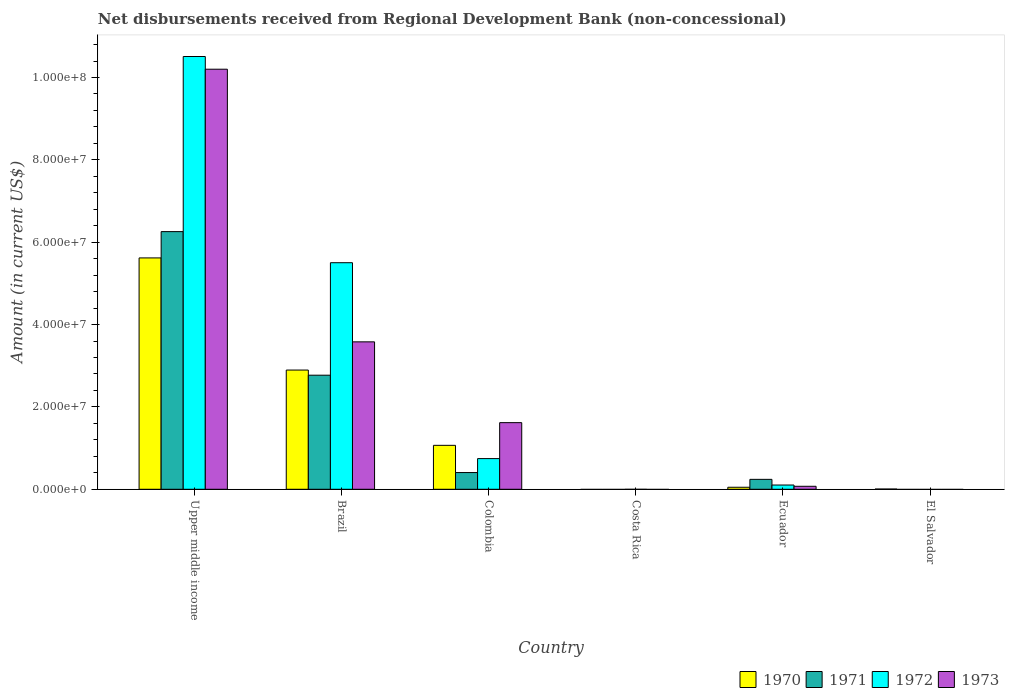How many different coloured bars are there?
Your response must be concise. 4. Are the number of bars per tick equal to the number of legend labels?
Your answer should be very brief. No. Are the number of bars on each tick of the X-axis equal?
Your answer should be very brief. No. How many bars are there on the 5th tick from the left?
Offer a very short reply. 4. How many bars are there on the 5th tick from the right?
Give a very brief answer. 4. What is the label of the 6th group of bars from the left?
Make the answer very short. El Salvador. What is the amount of disbursements received from Regional Development Bank in 1973 in Colombia?
Keep it short and to the point. 1.62e+07. Across all countries, what is the maximum amount of disbursements received from Regional Development Bank in 1973?
Offer a very short reply. 1.02e+08. Across all countries, what is the minimum amount of disbursements received from Regional Development Bank in 1973?
Provide a succinct answer. 0. In which country was the amount of disbursements received from Regional Development Bank in 1973 maximum?
Offer a very short reply. Upper middle income. What is the total amount of disbursements received from Regional Development Bank in 1972 in the graph?
Keep it short and to the point. 1.69e+08. What is the difference between the amount of disbursements received from Regional Development Bank in 1971 in Brazil and that in Ecuador?
Your answer should be compact. 2.53e+07. What is the difference between the amount of disbursements received from Regional Development Bank in 1970 in Upper middle income and the amount of disbursements received from Regional Development Bank in 1971 in Brazil?
Offer a very short reply. 2.85e+07. What is the average amount of disbursements received from Regional Development Bank in 1972 per country?
Ensure brevity in your answer.  2.81e+07. What is the difference between the amount of disbursements received from Regional Development Bank of/in 1973 and amount of disbursements received from Regional Development Bank of/in 1972 in Upper middle income?
Provide a succinct answer. -3.08e+06. What is the ratio of the amount of disbursements received from Regional Development Bank in 1972 in Colombia to that in Upper middle income?
Make the answer very short. 0.07. What is the difference between the highest and the second highest amount of disbursements received from Regional Development Bank in 1973?
Offer a very short reply. 8.58e+07. What is the difference between the highest and the lowest amount of disbursements received from Regional Development Bank in 1971?
Your response must be concise. 6.26e+07. Is the sum of the amount of disbursements received from Regional Development Bank in 1971 in Colombia and Ecuador greater than the maximum amount of disbursements received from Regional Development Bank in 1970 across all countries?
Offer a terse response. No. Is it the case that in every country, the sum of the amount of disbursements received from Regional Development Bank in 1973 and amount of disbursements received from Regional Development Bank in 1971 is greater than the amount of disbursements received from Regional Development Bank in 1970?
Your response must be concise. No. Are all the bars in the graph horizontal?
Provide a short and direct response. No. What is the difference between two consecutive major ticks on the Y-axis?
Your answer should be compact. 2.00e+07. Does the graph contain any zero values?
Provide a succinct answer. Yes. Does the graph contain grids?
Offer a terse response. No. What is the title of the graph?
Offer a terse response. Net disbursements received from Regional Development Bank (non-concessional). What is the Amount (in current US$) of 1970 in Upper middle income?
Give a very brief answer. 5.62e+07. What is the Amount (in current US$) in 1971 in Upper middle income?
Offer a terse response. 6.26e+07. What is the Amount (in current US$) in 1972 in Upper middle income?
Offer a very short reply. 1.05e+08. What is the Amount (in current US$) in 1973 in Upper middle income?
Your answer should be compact. 1.02e+08. What is the Amount (in current US$) in 1970 in Brazil?
Your response must be concise. 2.90e+07. What is the Amount (in current US$) in 1971 in Brazil?
Your answer should be very brief. 2.77e+07. What is the Amount (in current US$) in 1972 in Brazil?
Provide a succinct answer. 5.50e+07. What is the Amount (in current US$) in 1973 in Brazil?
Give a very brief answer. 3.58e+07. What is the Amount (in current US$) of 1970 in Colombia?
Keep it short and to the point. 1.07e+07. What is the Amount (in current US$) of 1971 in Colombia?
Offer a very short reply. 4.06e+06. What is the Amount (in current US$) in 1972 in Colombia?
Keep it short and to the point. 7.45e+06. What is the Amount (in current US$) of 1973 in Colombia?
Ensure brevity in your answer.  1.62e+07. What is the Amount (in current US$) of 1970 in Costa Rica?
Your answer should be compact. 0. What is the Amount (in current US$) of 1971 in Costa Rica?
Your response must be concise. 0. What is the Amount (in current US$) of 1970 in Ecuador?
Give a very brief answer. 4.89e+05. What is the Amount (in current US$) of 1971 in Ecuador?
Keep it short and to the point. 2.41e+06. What is the Amount (in current US$) of 1972 in Ecuador?
Offer a terse response. 1.03e+06. What is the Amount (in current US$) in 1973 in Ecuador?
Your answer should be very brief. 7.26e+05. What is the Amount (in current US$) in 1970 in El Salvador?
Your answer should be compact. 5.70e+04. What is the Amount (in current US$) in 1971 in El Salvador?
Your answer should be compact. 0. Across all countries, what is the maximum Amount (in current US$) in 1970?
Provide a short and direct response. 5.62e+07. Across all countries, what is the maximum Amount (in current US$) of 1971?
Your response must be concise. 6.26e+07. Across all countries, what is the maximum Amount (in current US$) of 1972?
Keep it short and to the point. 1.05e+08. Across all countries, what is the maximum Amount (in current US$) of 1973?
Provide a short and direct response. 1.02e+08. Across all countries, what is the minimum Amount (in current US$) of 1970?
Keep it short and to the point. 0. Across all countries, what is the minimum Amount (in current US$) in 1971?
Provide a succinct answer. 0. Across all countries, what is the minimum Amount (in current US$) of 1972?
Keep it short and to the point. 0. What is the total Amount (in current US$) in 1970 in the graph?
Your response must be concise. 9.64e+07. What is the total Amount (in current US$) in 1971 in the graph?
Make the answer very short. 9.68e+07. What is the total Amount (in current US$) of 1972 in the graph?
Provide a short and direct response. 1.69e+08. What is the total Amount (in current US$) of 1973 in the graph?
Your answer should be very brief. 1.55e+08. What is the difference between the Amount (in current US$) of 1970 in Upper middle income and that in Brazil?
Provide a short and direct response. 2.72e+07. What is the difference between the Amount (in current US$) of 1971 in Upper middle income and that in Brazil?
Your response must be concise. 3.49e+07. What is the difference between the Amount (in current US$) in 1972 in Upper middle income and that in Brazil?
Give a very brief answer. 5.01e+07. What is the difference between the Amount (in current US$) in 1973 in Upper middle income and that in Brazil?
Give a very brief answer. 6.62e+07. What is the difference between the Amount (in current US$) of 1970 in Upper middle income and that in Colombia?
Provide a succinct answer. 4.55e+07. What is the difference between the Amount (in current US$) of 1971 in Upper middle income and that in Colombia?
Provide a succinct answer. 5.85e+07. What is the difference between the Amount (in current US$) of 1972 in Upper middle income and that in Colombia?
Provide a short and direct response. 9.76e+07. What is the difference between the Amount (in current US$) of 1973 in Upper middle income and that in Colombia?
Make the answer very short. 8.58e+07. What is the difference between the Amount (in current US$) in 1970 in Upper middle income and that in Ecuador?
Keep it short and to the point. 5.57e+07. What is the difference between the Amount (in current US$) in 1971 in Upper middle income and that in Ecuador?
Give a very brief answer. 6.02e+07. What is the difference between the Amount (in current US$) of 1972 in Upper middle income and that in Ecuador?
Make the answer very short. 1.04e+08. What is the difference between the Amount (in current US$) in 1973 in Upper middle income and that in Ecuador?
Offer a very short reply. 1.01e+08. What is the difference between the Amount (in current US$) of 1970 in Upper middle income and that in El Salvador?
Keep it short and to the point. 5.61e+07. What is the difference between the Amount (in current US$) in 1970 in Brazil and that in Colombia?
Make the answer very short. 1.83e+07. What is the difference between the Amount (in current US$) of 1971 in Brazil and that in Colombia?
Ensure brevity in your answer.  2.36e+07. What is the difference between the Amount (in current US$) of 1972 in Brazil and that in Colombia?
Give a very brief answer. 4.76e+07. What is the difference between the Amount (in current US$) of 1973 in Brazil and that in Colombia?
Your answer should be compact. 1.96e+07. What is the difference between the Amount (in current US$) in 1970 in Brazil and that in Ecuador?
Offer a terse response. 2.85e+07. What is the difference between the Amount (in current US$) in 1971 in Brazil and that in Ecuador?
Provide a succinct answer. 2.53e+07. What is the difference between the Amount (in current US$) in 1972 in Brazil and that in Ecuador?
Offer a very short reply. 5.40e+07. What is the difference between the Amount (in current US$) of 1973 in Brazil and that in Ecuador?
Provide a short and direct response. 3.51e+07. What is the difference between the Amount (in current US$) of 1970 in Brazil and that in El Salvador?
Provide a succinct answer. 2.89e+07. What is the difference between the Amount (in current US$) of 1970 in Colombia and that in Ecuador?
Your response must be concise. 1.02e+07. What is the difference between the Amount (in current US$) of 1971 in Colombia and that in Ecuador?
Provide a succinct answer. 1.65e+06. What is the difference between the Amount (in current US$) of 1972 in Colombia and that in Ecuador?
Your answer should be very brief. 6.42e+06. What is the difference between the Amount (in current US$) of 1973 in Colombia and that in Ecuador?
Make the answer very short. 1.55e+07. What is the difference between the Amount (in current US$) in 1970 in Colombia and that in El Salvador?
Provide a succinct answer. 1.06e+07. What is the difference between the Amount (in current US$) of 1970 in Ecuador and that in El Salvador?
Your answer should be very brief. 4.32e+05. What is the difference between the Amount (in current US$) of 1970 in Upper middle income and the Amount (in current US$) of 1971 in Brazil?
Give a very brief answer. 2.85e+07. What is the difference between the Amount (in current US$) in 1970 in Upper middle income and the Amount (in current US$) in 1972 in Brazil?
Your answer should be compact. 1.16e+06. What is the difference between the Amount (in current US$) in 1970 in Upper middle income and the Amount (in current US$) in 1973 in Brazil?
Keep it short and to the point. 2.04e+07. What is the difference between the Amount (in current US$) in 1971 in Upper middle income and the Amount (in current US$) in 1972 in Brazil?
Give a very brief answer. 7.55e+06. What is the difference between the Amount (in current US$) of 1971 in Upper middle income and the Amount (in current US$) of 1973 in Brazil?
Give a very brief answer. 2.68e+07. What is the difference between the Amount (in current US$) of 1972 in Upper middle income and the Amount (in current US$) of 1973 in Brazil?
Provide a short and direct response. 6.93e+07. What is the difference between the Amount (in current US$) of 1970 in Upper middle income and the Amount (in current US$) of 1971 in Colombia?
Your answer should be compact. 5.21e+07. What is the difference between the Amount (in current US$) in 1970 in Upper middle income and the Amount (in current US$) in 1972 in Colombia?
Ensure brevity in your answer.  4.87e+07. What is the difference between the Amount (in current US$) in 1970 in Upper middle income and the Amount (in current US$) in 1973 in Colombia?
Your answer should be compact. 4.00e+07. What is the difference between the Amount (in current US$) in 1971 in Upper middle income and the Amount (in current US$) in 1972 in Colombia?
Your answer should be very brief. 5.51e+07. What is the difference between the Amount (in current US$) in 1971 in Upper middle income and the Amount (in current US$) in 1973 in Colombia?
Your answer should be very brief. 4.64e+07. What is the difference between the Amount (in current US$) in 1972 in Upper middle income and the Amount (in current US$) in 1973 in Colombia?
Give a very brief answer. 8.89e+07. What is the difference between the Amount (in current US$) in 1970 in Upper middle income and the Amount (in current US$) in 1971 in Ecuador?
Your answer should be very brief. 5.38e+07. What is the difference between the Amount (in current US$) in 1970 in Upper middle income and the Amount (in current US$) in 1972 in Ecuador?
Your answer should be very brief. 5.52e+07. What is the difference between the Amount (in current US$) in 1970 in Upper middle income and the Amount (in current US$) in 1973 in Ecuador?
Make the answer very short. 5.55e+07. What is the difference between the Amount (in current US$) of 1971 in Upper middle income and the Amount (in current US$) of 1972 in Ecuador?
Your answer should be very brief. 6.15e+07. What is the difference between the Amount (in current US$) of 1971 in Upper middle income and the Amount (in current US$) of 1973 in Ecuador?
Provide a succinct answer. 6.18e+07. What is the difference between the Amount (in current US$) in 1972 in Upper middle income and the Amount (in current US$) in 1973 in Ecuador?
Ensure brevity in your answer.  1.04e+08. What is the difference between the Amount (in current US$) of 1970 in Brazil and the Amount (in current US$) of 1971 in Colombia?
Your response must be concise. 2.49e+07. What is the difference between the Amount (in current US$) of 1970 in Brazil and the Amount (in current US$) of 1972 in Colombia?
Your answer should be compact. 2.15e+07. What is the difference between the Amount (in current US$) of 1970 in Brazil and the Amount (in current US$) of 1973 in Colombia?
Give a very brief answer. 1.28e+07. What is the difference between the Amount (in current US$) of 1971 in Brazil and the Amount (in current US$) of 1972 in Colombia?
Offer a very short reply. 2.03e+07. What is the difference between the Amount (in current US$) in 1971 in Brazil and the Amount (in current US$) in 1973 in Colombia?
Offer a terse response. 1.15e+07. What is the difference between the Amount (in current US$) in 1972 in Brazil and the Amount (in current US$) in 1973 in Colombia?
Make the answer very short. 3.88e+07. What is the difference between the Amount (in current US$) in 1970 in Brazil and the Amount (in current US$) in 1971 in Ecuador?
Your response must be concise. 2.65e+07. What is the difference between the Amount (in current US$) of 1970 in Brazil and the Amount (in current US$) of 1972 in Ecuador?
Ensure brevity in your answer.  2.79e+07. What is the difference between the Amount (in current US$) in 1970 in Brazil and the Amount (in current US$) in 1973 in Ecuador?
Your answer should be very brief. 2.82e+07. What is the difference between the Amount (in current US$) of 1971 in Brazil and the Amount (in current US$) of 1972 in Ecuador?
Offer a very short reply. 2.67e+07. What is the difference between the Amount (in current US$) of 1971 in Brazil and the Amount (in current US$) of 1973 in Ecuador?
Offer a terse response. 2.70e+07. What is the difference between the Amount (in current US$) of 1972 in Brazil and the Amount (in current US$) of 1973 in Ecuador?
Your response must be concise. 5.43e+07. What is the difference between the Amount (in current US$) in 1970 in Colombia and the Amount (in current US$) in 1971 in Ecuador?
Make the answer very short. 8.26e+06. What is the difference between the Amount (in current US$) in 1970 in Colombia and the Amount (in current US$) in 1972 in Ecuador?
Give a very brief answer. 9.64e+06. What is the difference between the Amount (in current US$) in 1970 in Colombia and the Amount (in current US$) in 1973 in Ecuador?
Your answer should be compact. 9.94e+06. What is the difference between the Amount (in current US$) of 1971 in Colombia and the Amount (in current US$) of 1972 in Ecuador?
Make the answer very short. 3.03e+06. What is the difference between the Amount (in current US$) in 1971 in Colombia and the Amount (in current US$) in 1973 in Ecuador?
Ensure brevity in your answer.  3.34e+06. What is the difference between the Amount (in current US$) of 1972 in Colombia and the Amount (in current US$) of 1973 in Ecuador?
Provide a short and direct response. 6.72e+06. What is the average Amount (in current US$) of 1970 per country?
Give a very brief answer. 1.61e+07. What is the average Amount (in current US$) of 1971 per country?
Ensure brevity in your answer.  1.61e+07. What is the average Amount (in current US$) of 1972 per country?
Give a very brief answer. 2.81e+07. What is the average Amount (in current US$) of 1973 per country?
Offer a very short reply. 2.58e+07. What is the difference between the Amount (in current US$) in 1970 and Amount (in current US$) in 1971 in Upper middle income?
Your answer should be compact. -6.39e+06. What is the difference between the Amount (in current US$) in 1970 and Amount (in current US$) in 1972 in Upper middle income?
Your answer should be very brief. -4.89e+07. What is the difference between the Amount (in current US$) of 1970 and Amount (in current US$) of 1973 in Upper middle income?
Your answer should be compact. -4.58e+07. What is the difference between the Amount (in current US$) of 1971 and Amount (in current US$) of 1972 in Upper middle income?
Offer a very short reply. -4.25e+07. What is the difference between the Amount (in current US$) of 1971 and Amount (in current US$) of 1973 in Upper middle income?
Keep it short and to the point. -3.94e+07. What is the difference between the Amount (in current US$) of 1972 and Amount (in current US$) of 1973 in Upper middle income?
Your answer should be compact. 3.08e+06. What is the difference between the Amount (in current US$) of 1970 and Amount (in current US$) of 1971 in Brazil?
Ensure brevity in your answer.  1.25e+06. What is the difference between the Amount (in current US$) in 1970 and Amount (in current US$) in 1972 in Brazil?
Your answer should be very brief. -2.61e+07. What is the difference between the Amount (in current US$) in 1970 and Amount (in current US$) in 1973 in Brazil?
Your answer should be compact. -6.85e+06. What is the difference between the Amount (in current US$) of 1971 and Amount (in current US$) of 1972 in Brazil?
Ensure brevity in your answer.  -2.73e+07. What is the difference between the Amount (in current US$) of 1971 and Amount (in current US$) of 1973 in Brazil?
Ensure brevity in your answer.  -8.10e+06. What is the difference between the Amount (in current US$) of 1972 and Amount (in current US$) of 1973 in Brazil?
Your answer should be compact. 1.92e+07. What is the difference between the Amount (in current US$) in 1970 and Amount (in current US$) in 1971 in Colombia?
Your answer should be very brief. 6.61e+06. What is the difference between the Amount (in current US$) of 1970 and Amount (in current US$) of 1972 in Colombia?
Your answer should be compact. 3.22e+06. What is the difference between the Amount (in current US$) in 1970 and Amount (in current US$) in 1973 in Colombia?
Offer a very short reply. -5.51e+06. What is the difference between the Amount (in current US$) of 1971 and Amount (in current US$) of 1972 in Colombia?
Offer a terse response. -3.39e+06. What is the difference between the Amount (in current US$) in 1971 and Amount (in current US$) in 1973 in Colombia?
Keep it short and to the point. -1.21e+07. What is the difference between the Amount (in current US$) in 1972 and Amount (in current US$) in 1973 in Colombia?
Your response must be concise. -8.73e+06. What is the difference between the Amount (in current US$) in 1970 and Amount (in current US$) in 1971 in Ecuador?
Make the answer very short. -1.92e+06. What is the difference between the Amount (in current US$) of 1970 and Amount (in current US$) of 1972 in Ecuador?
Make the answer very short. -5.42e+05. What is the difference between the Amount (in current US$) of 1970 and Amount (in current US$) of 1973 in Ecuador?
Keep it short and to the point. -2.37e+05. What is the difference between the Amount (in current US$) in 1971 and Amount (in current US$) in 1972 in Ecuador?
Ensure brevity in your answer.  1.38e+06. What is the difference between the Amount (in current US$) in 1971 and Amount (in current US$) in 1973 in Ecuador?
Your response must be concise. 1.68e+06. What is the difference between the Amount (in current US$) in 1972 and Amount (in current US$) in 1973 in Ecuador?
Your answer should be very brief. 3.05e+05. What is the ratio of the Amount (in current US$) of 1970 in Upper middle income to that in Brazil?
Your response must be concise. 1.94. What is the ratio of the Amount (in current US$) of 1971 in Upper middle income to that in Brazil?
Ensure brevity in your answer.  2.26. What is the ratio of the Amount (in current US$) in 1972 in Upper middle income to that in Brazil?
Your response must be concise. 1.91. What is the ratio of the Amount (in current US$) of 1973 in Upper middle income to that in Brazil?
Ensure brevity in your answer.  2.85. What is the ratio of the Amount (in current US$) of 1970 in Upper middle income to that in Colombia?
Your response must be concise. 5.27. What is the ratio of the Amount (in current US$) of 1971 in Upper middle income to that in Colombia?
Give a very brief answer. 15.4. What is the ratio of the Amount (in current US$) in 1972 in Upper middle income to that in Colombia?
Your response must be concise. 14.11. What is the ratio of the Amount (in current US$) in 1973 in Upper middle income to that in Colombia?
Make the answer very short. 6.3. What is the ratio of the Amount (in current US$) of 1970 in Upper middle income to that in Ecuador?
Give a very brief answer. 114.9. What is the ratio of the Amount (in current US$) of 1971 in Upper middle income to that in Ecuador?
Provide a succinct answer. 25.95. What is the ratio of the Amount (in current US$) of 1972 in Upper middle income to that in Ecuador?
Provide a short and direct response. 101.94. What is the ratio of the Amount (in current US$) of 1973 in Upper middle income to that in Ecuador?
Provide a short and direct response. 140.52. What is the ratio of the Amount (in current US$) in 1970 in Upper middle income to that in El Salvador?
Your answer should be compact. 985.7. What is the ratio of the Amount (in current US$) in 1970 in Brazil to that in Colombia?
Offer a terse response. 2.71. What is the ratio of the Amount (in current US$) of 1971 in Brazil to that in Colombia?
Your answer should be compact. 6.82. What is the ratio of the Amount (in current US$) in 1972 in Brazil to that in Colombia?
Provide a short and direct response. 7.39. What is the ratio of the Amount (in current US$) in 1973 in Brazil to that in Colombia?
Provide a short and direct response. 2.21. What is the ratio of the Amount (in current US$) in 1970 in Brazil to that in Ecuador?
Your response must be concise. 59.21. What is the ratio of the Amount (in current US$) in 1971 in Brazil to that in Ecuador?
Ensure brevity in your answer.  11.49. What is the ratio of the Amount (in current US$) of 1972 in Brazil to that in Ecuador?
Keep it short and to the point. 53.37. What is the ratio of the Amount (in current US$) in 1973 in Brazil to that in Ecuador?
Your response must be concise. 49.31. What is the ratio of the Amount (in current US$) of 1970 in Brazil to that in El Salvador?
Offer a very short reply. 507.93. What is the ratio of the Amount (in current US$) in 1970 in Colombia to that in Ecuador?
Provide a short and direct response. 21.82. What is the ratio of the Amount (in current US$) in 1971 in Colombia to that in Ecuador?
Provide a succinct answer. 1.68. What is the ratio of the Amount (in current US$) of 1972 in Colombia to that in Ecuador?
Your answer should be very brief. 7.23. What is the ratio of the Amount (in current US$) in 1973 in Colombia to that in Ecuador?
Your answer should be very brief. 22.29. What is the ratio of the Amount (in current US$) of 1970 in Colombia to that in El Salvador?
Provide a short and direct response. 187.19. What is the ratio of the Amount (in current US$) in 1970 in Ecuador to that in El Salvador?
Your response must be concise. 8.58. What is the difference between the highest and the second highest Amount (in current US$) in 1970?
Keep it short and to the point. 2.72e+07. What is the difference between the highest and the second highest Amount (in current US$) in 1971?
Offer a very short reply. 3.49e+07. What is the difference between the highest and the second highest Amount (in current US$) in 1972?
Your answer should be compact. 5.01e+07. What is the difference between the highest and the second highest Amount (in current US$) of 1973?
Give a very brief answer. 6.62e+07. What is the difference between the highest and the lowest Amount (in current US$) in 1970?
Make the answer very short. 5.62e+07. What is the difference between the highest and the lowest Amount (in current US$) in 1971?
Your answer should be very brief. 6.26e+07. What is the difference between the highest and the lowest Amount (in current US$) of 1972?
Provide a succinct answer. 1.05e+08. What is the difference between the highest and the lowest Amount (in current US$) in 1973?
Provide a short and direct response. 1.02e+08. 